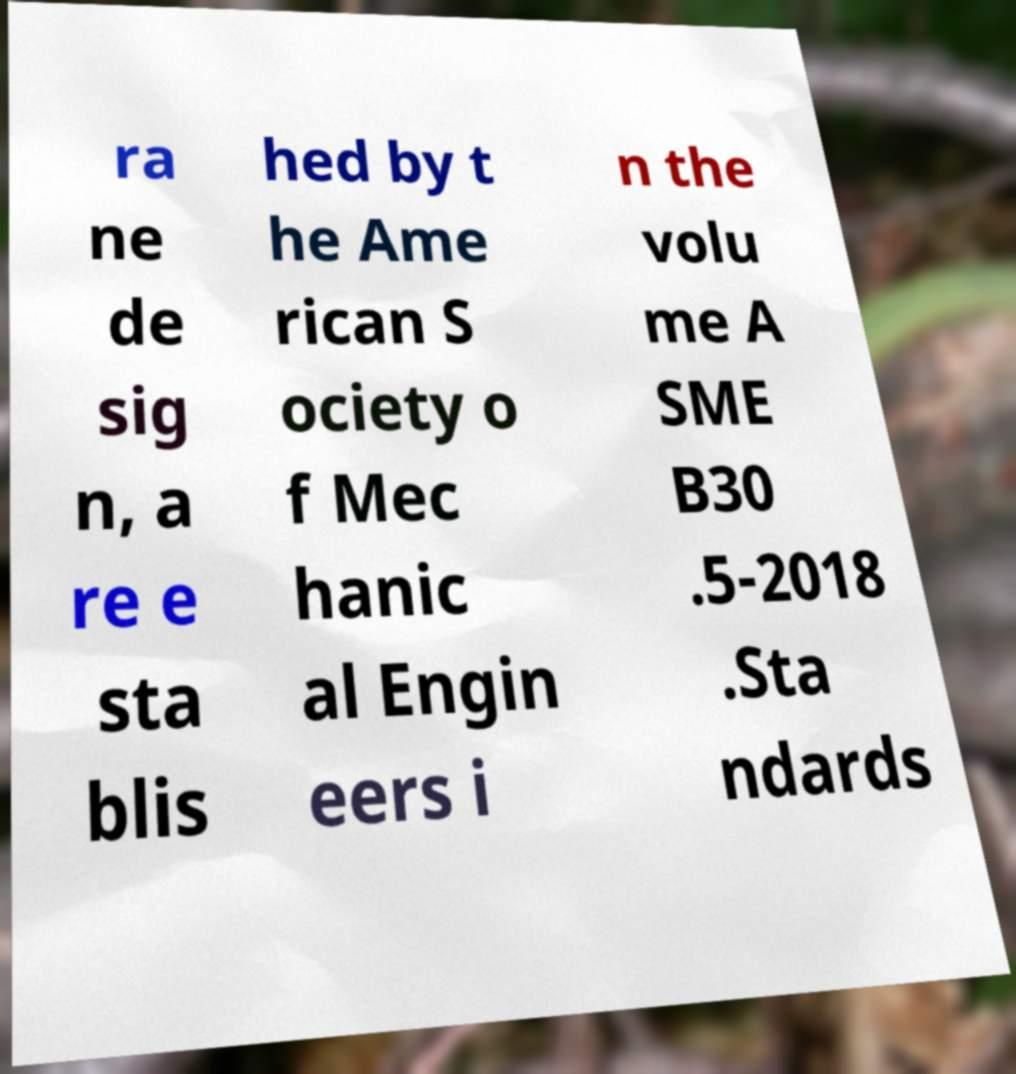Please read and relay the text visible in this image. What does it say? ra ne de sig n, a re e sta blis hed by t he Ame rican S ociety o f Mec hanic al Engin eers i n the volu me A SME B30 .5-2018 .Sta ndards 